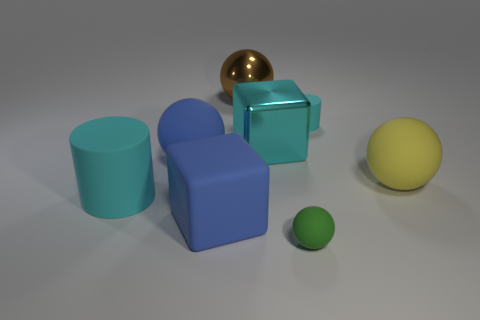Is there a red shiny object of the same shape as the big cyan rubber thing?
Offer a very short reply. No. How many blocks are made of the same material as the green thing?
Your response must be concise. 1. Does the block that is to the left of the brown thing have the same material as the blue ball?
Make the answer very short. Yes. Is the number of yellow objects in front of the large cylinder greater than the number of big blue rubber things that are behind the rubber block?
Provide a succinct answer. No. What material is the yellow ball that is the same size as the blue cube?
Give a very brief answer. Rubber. What number of other objects are the same material as the small cyan cylinder?
Offer a terse response. 5. Is the shape of the small cyan object that is to the right of the tiny green rubber thing the same as the large cyan thing left of the big cyan cube?
Offer a very short reply. Yes. How many other things are there of the same color as the large metallic ball?
Give a very brief answer. 0. Do the large ball that is on the left side of the rubber cube and the large blue object that is in front of the yellow thing have the same material?
Keep it short and to the point. Yes. Are there the same number of cyan rubber cylinders that are to the left of the brown shiny thing and big cylinders left of the big cyan matte cylinder?
Provide a succinct answer. No. 